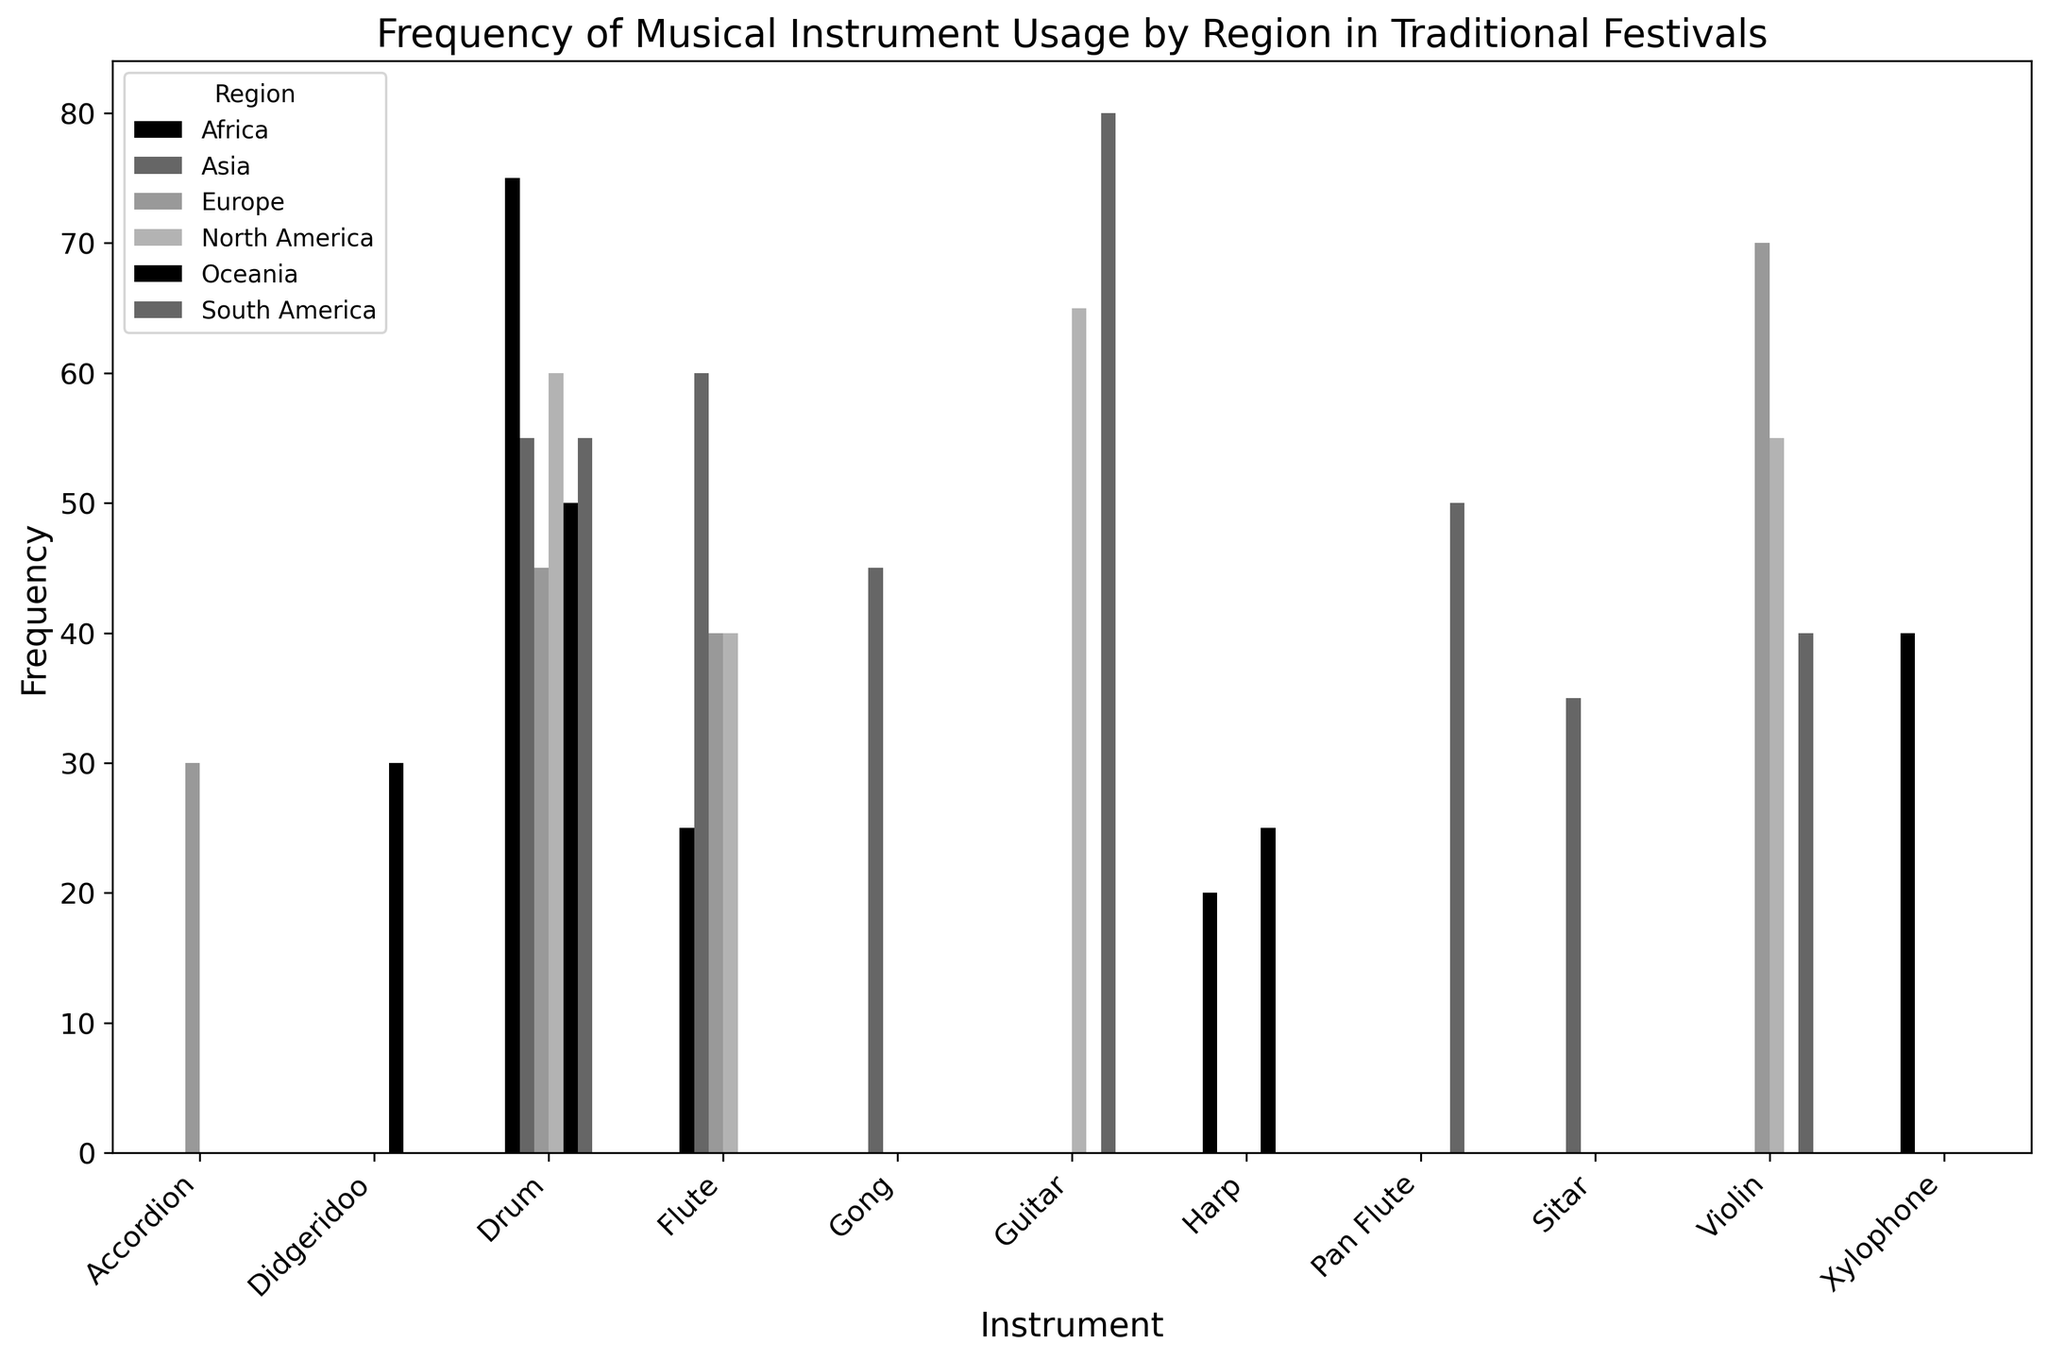How many regions use the flute in traditional festivals? The bar chart shows the frequency of flute usage in different regions. Count the number of bars representing the flute across various regions. The regions are Africa, Asia, Europe, and North America.
Answer: 4 Which region uses the guitar most frequently? Look for the tallest bar in the 'Guitar' group. The tallest bar represents the region with the highest frequency.
Answer: South America What is the total frequency of drum usage in all regions combined? Identify the heights of all bars representing drums in each region: Africa (75), Asia (55), Europe (45), North America (60), South America (55), Oceania (50). Summing these up gives 75 + 55 + 45 + 60 + 55 + 50 = 340
Answer: 340 Which instrument is used most frequently in Europe? Compare the heights of all bars within the 'Europe' group. The tallest bar indicates the most frequently used instrument.
Answer: Violin Between Pan Flute and Didgeridoo, which instrument has a higher frequency in Oceania? Compare the height of the bar for 'Pan Flute' and 'Didgeridoo' under the 'Oceania' group.
Answer: Didgeridoo How does harp usage in Africa compare to harp usage in Oceania? Look at the bars representing 'Harp' in both Africa and Oceania. Note the respective heights and compare them.
Answer: Africa has higher usage What is the combined frequency of Sitar and Gong usage in Asia? Identify the heights of the bars for Sitar (35) and Gong (45) under the 'Asia' group. Summing these up gives 35 + 45 = 80
Answer: 80 Which instrument has the least frequency in North America, and what is that frequency? Compare the heights of the bars within the 'North America' group. The shortest bar indicates the least frequent instrument.
Answer: Flute, 40 Is the xylophone used outside of Africa? Check if there are any bars representing 'Xylophone' outside the 'Africa' group.
Answer: No What is the difference in drum frequency between North America and South America? Note the heights of the bars representing 'Drum' in North America (60) and South America (55) and subtract the latter from the former: 60 - 55.
Answer: 5 